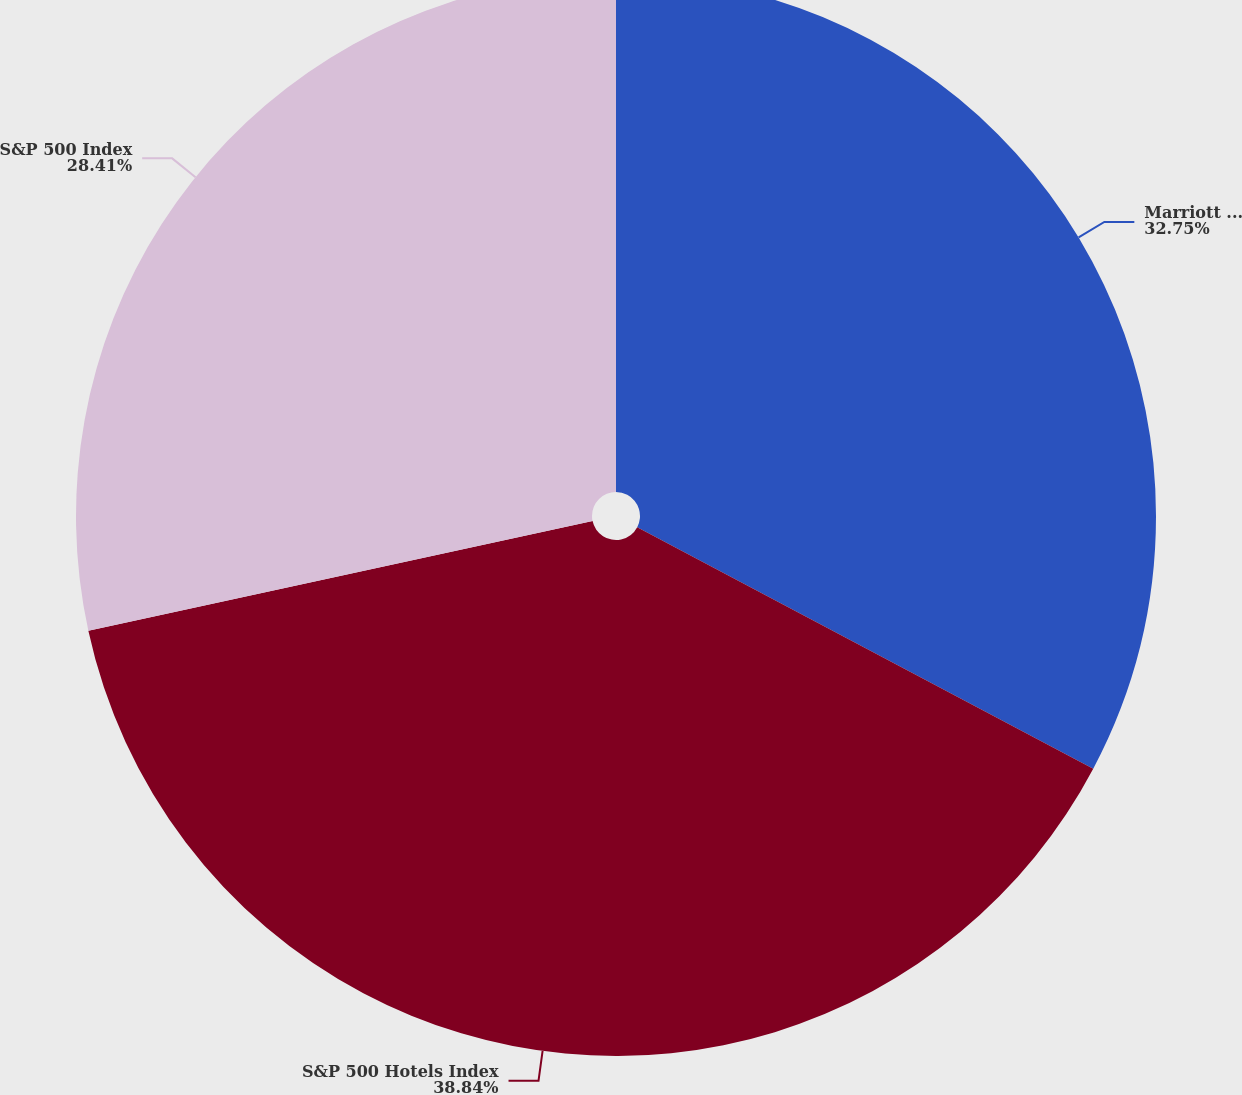Convert chart. <chart><loc_0><loc_0><loc_500><loc_500><pie_chart><fcel>Marriott International Inc<fcel>S&P 500 Hotels Index<fcel>S&P 500 Index<nl><fcel>32.75%<fcel>38.84%<fcel>28.41%<nl></chart> 